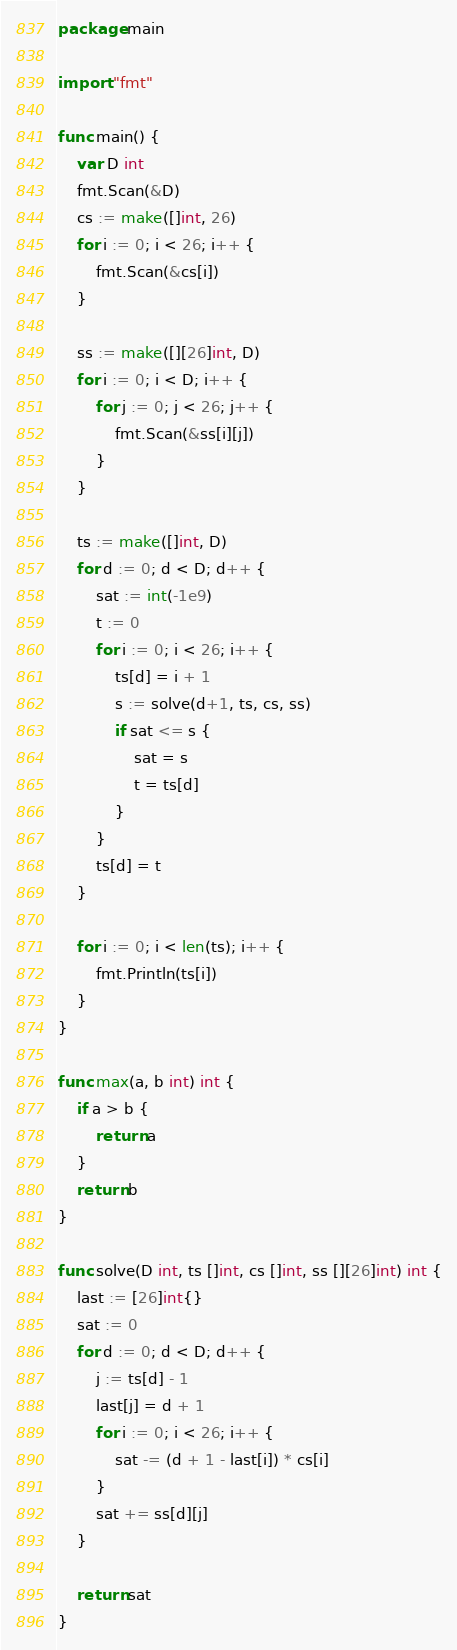<code> <loc_0><loc_0><loc_500><loc_500><_Go_>package main

import "fmt"

func main() {
	var D int
	fmt.Scan(&D)
	cs := make([]int, 26)
	for i := 0; i < 26; i++ {
		fmt.Scan(&cs[i])
	}

	ss := make([][26]int, D)
	for i := 0; i < D; i++ {
		for j := 0; j < 26; j++ {
			fmt.Scan(&ss[i][j])
		}
	}

	ts := make([]int, D)
	for d := 0; d < D; d++ {
		sat := int(-1e9)
		t := 0
		for i := 0; i < 26; i++ {
			ts[d] = i + 1
			s := solve(d+1, ts, cs, ss)
			if sat <= s {
				sat = s
				t = ts[d]
			}
		}
		ts[d] = t
	}

	for i := 0; i < len(ts); i++ {
		fmt.Println(ts[i])
	}
}

func max(a, b int) int {
	if a > b {
		return a
	}
	return b
}

func solve(D int, ts []int, cs []int, ss [][26]int) int {
	last := [26]int{}
	sat := 0
	for d := 0; d < D; d++ {
		j := ts[d] - 1
		last[j] = d + 1
		for i := 0; i < 26; i++ {
			sat -= (d + 1 - last[i]) * cs[i]
		}
		sat += ss[d][j]
	}

	return sat
}
</code> 